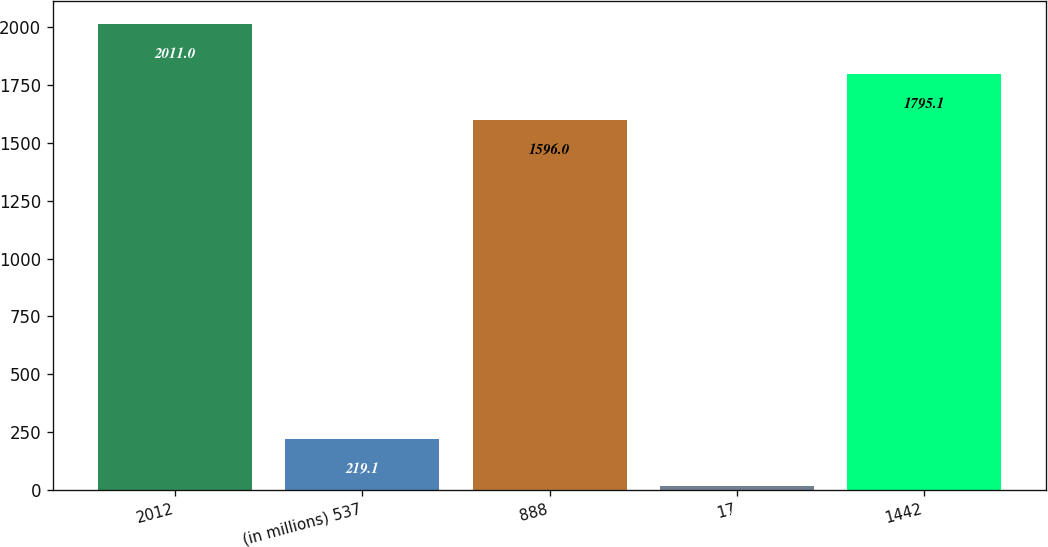<chart> <loc_0><loc_0><loc_500><loc_500><bar_chart><fcel>2012<fcel>(in millions) 537<fcel>888<fcel>17<fcel>1442<nl><fcel>2011<fcel>219.1<fcel>1596<fcel>20<fcel>1795.1<nl></chart> 